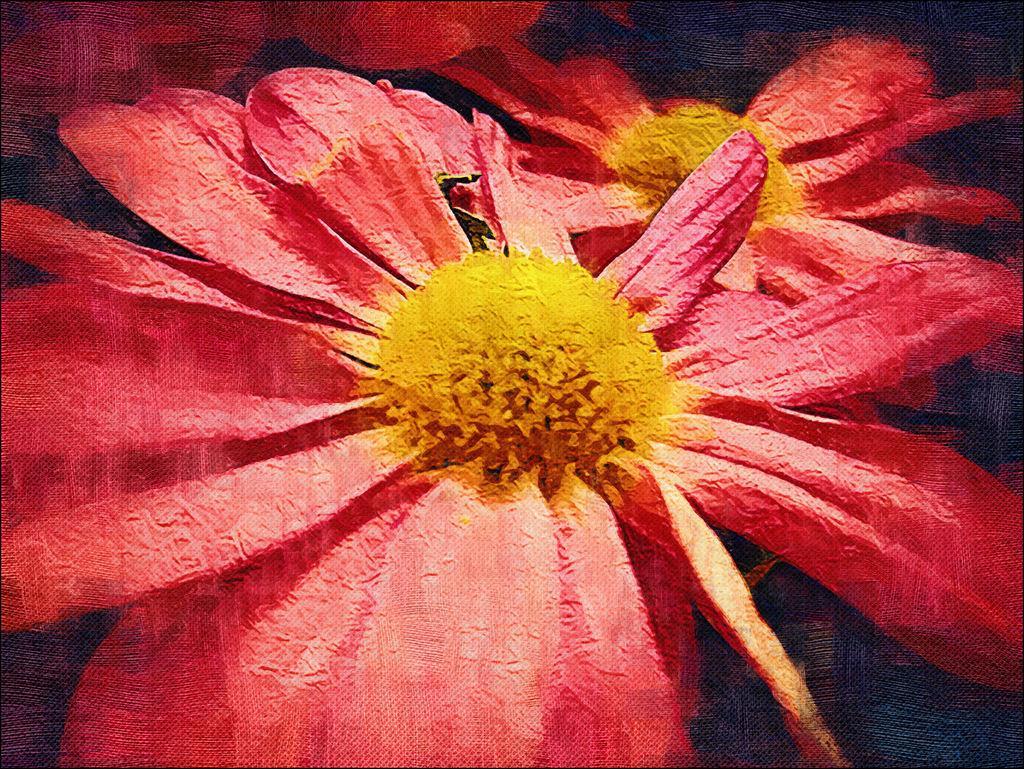How would you summarize this image in a sentence or two? It is a poster. In this image, we can see few flowers. 